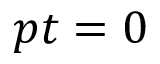Convert formula to latex. <formula><loc_0><loc_0><loc_500><loc_500>p t = 0</formula> 